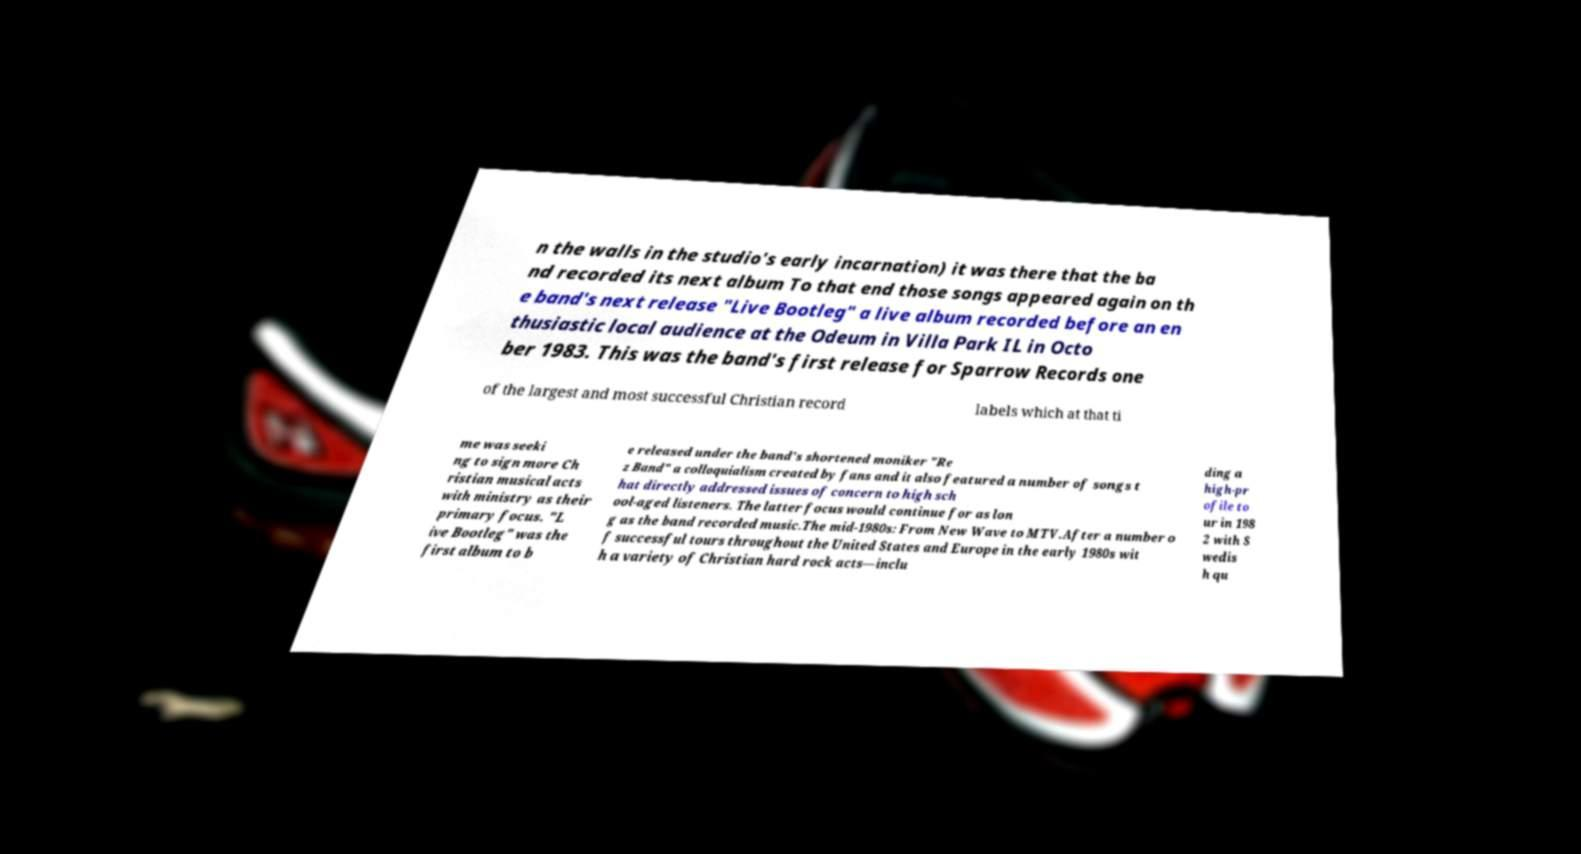Please read and relay the text visible in this image. What does it say? n the walls in the studio's early incarnation) it was there that the ba nd recorded its next album To that end those songs appeared again on th e band's next release "Live Bootleg" a live album recorded before an en thusiastic local audience at the Odeum in Villa Park IL in Octo ber 1983. This was the band's first release for Sparrow Records one of the largest and most successful Christian record labels which at that ti me was seeki ng to sign more Ch ristian musical acts with ministry as their primary focus. "L ive Bootleg" was the first album to b e released under the band's shortened moniker "Re z Band" a colloquialism created by fans and it also featured a number of songs t hat directly addressed issues of concern to high sch ool-aged listeners. The latter focus would continue for as lon g as the band recorded music.The mid-1980s: From New Wave to MTV.After a number o f successful tours throughout the United States and Europe in the early 1980s wit h a variety of Christian hard rock acts—inclu ding a high-pr ofile to ur in 198 2 with S wedis h qu 